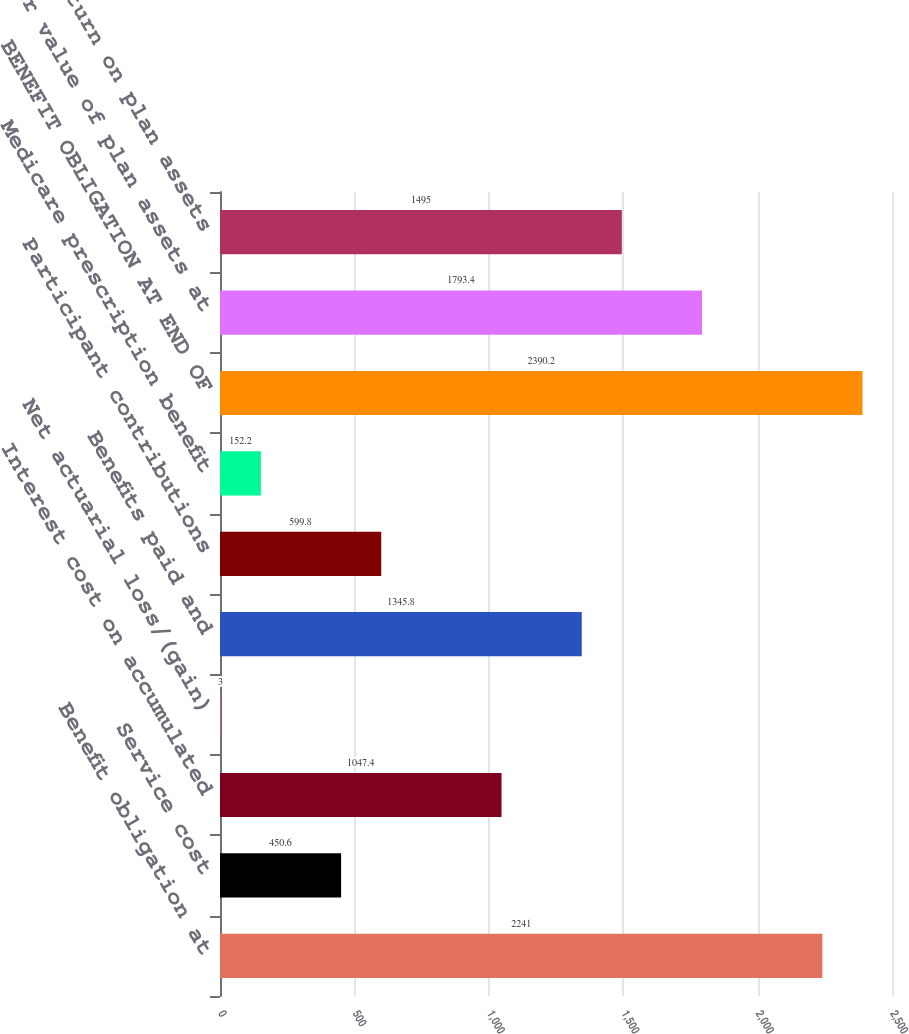Convert chart to OTSL. <chart><loc_0><loc_0><loc_500><loc_500><bar_chart><fcel>Benefit obligation at<fcel>Service cost<fcel>Interest cost on accumulated<fcel>Net actuarial loss/(gain)<fcel>Benefits paid and<fcel>Participant contributions<fcel>Medicare prescription benefit<fcel>BENEFIT OBLIGATION AT END OF<fcel>Fair value of plan assets at<fcel>Actual return on plan assets<nl><fcel>2241<fcel>450.6<fcel>1047.4<fcel>3<fcel>1345.8<fcel>599.8<fcel>152.2<fcel>2390.2<fcel>1793.4<fcel>1495<nl></chart> 